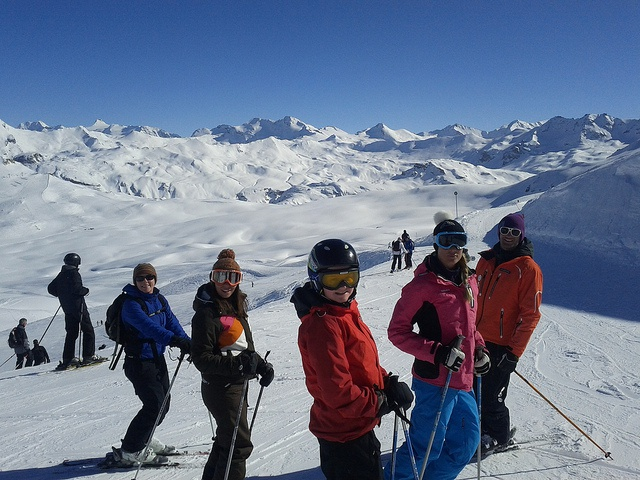Describe the objects in this image and their specific colors. I can see people in blue, black, navy, maroon, and gray tones, people in blue, black, maroon, brown, and gray tones, people in blue, black, navy, darkgray, and gray tones, people in blue, black, gray, maroon, and darkgray tones, and people in blue, black, maroon, and gray tones in this image. 